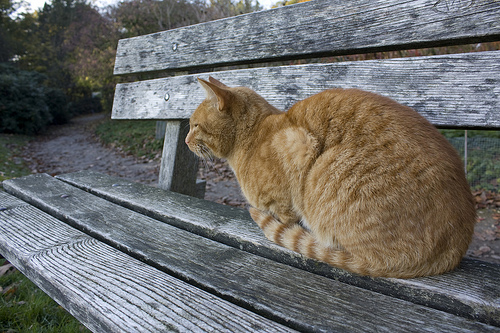Imagine a story involving the cat on the bench. Once upon a time, in a quiet park surrounded by lush greenery, a golden cat named Whiskers sat majestically on a rustic wooden bench. Whiskers had a special spot here, where she would spend her afternoons basking in the warm, golden sunlight. Today was no different. She gazed intently down the winding path, as if anticipating a special visitor. As the day unfolded, Whiskers' friend, a cheerful bird named Chirp, fluttered down next to her. Together, they shared stories about their adventures—Whiskers spoke of her nighttime prowls and Chirp shared tales of his sky-high escapades. As the sun began to set, casting a warm orange hue over the park, Whiskers and Chirp knew they had shared yet another day of friendship and laughter... 